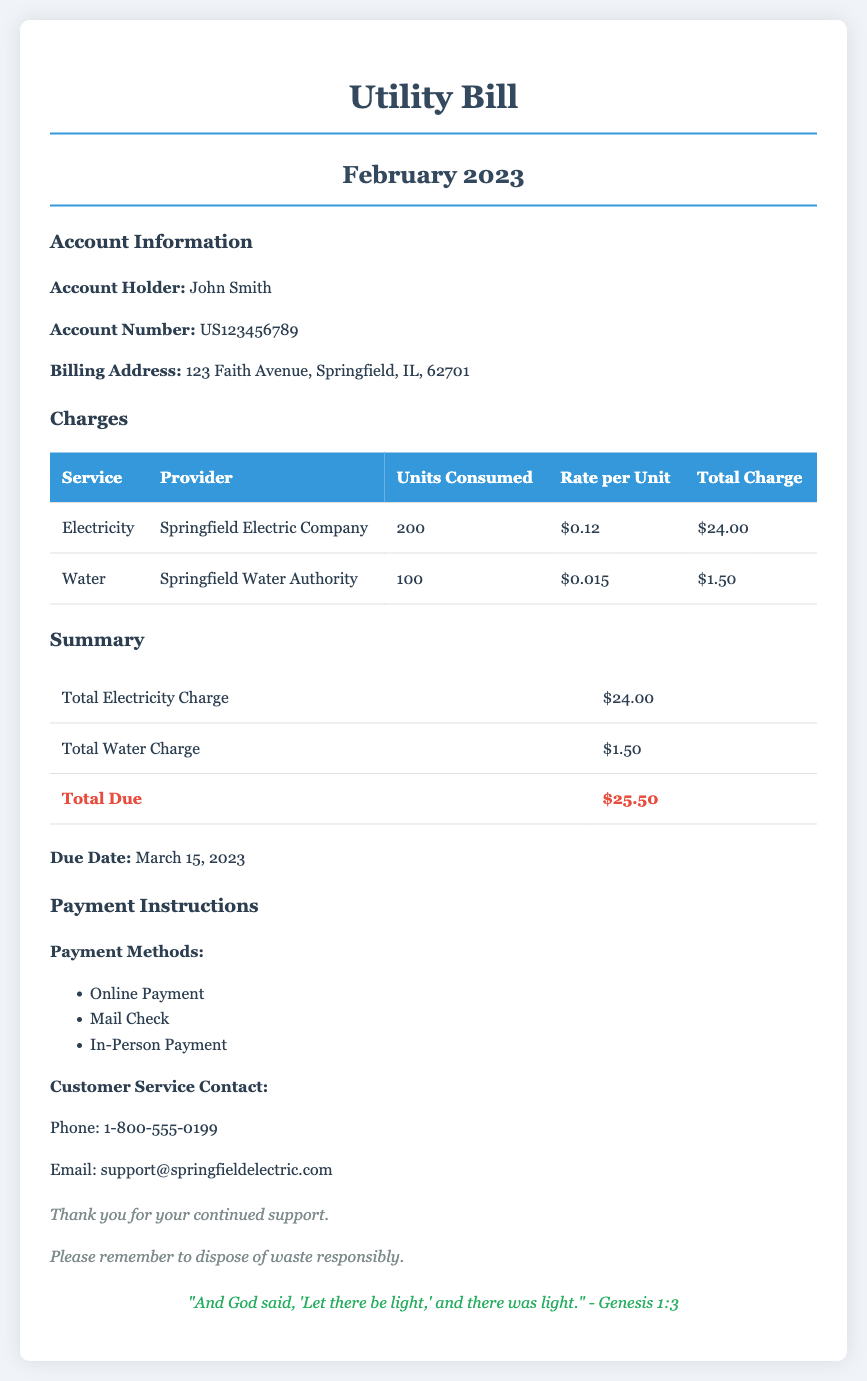What is the total due amount on the bill? The total due amount is presented in the summary section of the document, which is $25.50.
Answer: $25.50 Who is the account holder? The account holder's name is stated in the account information section, which is John Smith.
Answer: John Smith What is the rate per unit for electricity? The rate per unit for electricity is listed in the charges table, which is $0.12.
Answer: $0.12 When is the due date for the payment? The due date is mentioned in the summary section of the document, which is March 15, 2023.
Answer: March 15, 2023 How many units of water were consumed? The units of water consumed are shown in the charges table, which states 100 units.
Answer: 100 What is the total charge for water? The total charge for water can be found in the charges table, listed as $1.50.
Answer: $1.50 Who can be contacted for customer service? The customer service contact information is provided under the payment instructions section, which lists Phone: 1-800-555-0199.
Answer: 1-800-555-0199 What is the provider of the electricity service? The service provider for electricity is mentioned in the charges table, which is Springfield Electric Company.
Answer: Springfield Electric Company How much was charged for each unit of water? The charge per unit for water is specified in the charges table as $0.015.
Answer: $0.015 